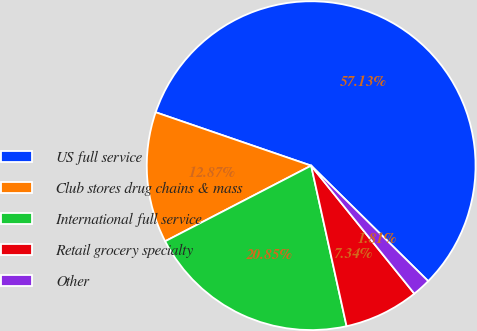<chart> <loc_0><loc_0><loc_500><loc_500><pie_chart><fcel>US full service<fcel>Club stores drug chains & mass<fcel>International full service<fcel>Retail grocery specialty<fcel>Other<nl><fcel>57.12%<fcel>12.87%<fcel>20.85%<fcel>7.34%<fcel>1.81%<nl></chart> 